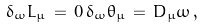<formula> <loc_0><loc_0><loc_500><loc_500>\delta _ { \omega } L _ { \mu } \, = \, 0 \, \delta _ { \omega } \theta _ { \mu } \, = \, D _ { \mu } \omega \, ,</formula> 